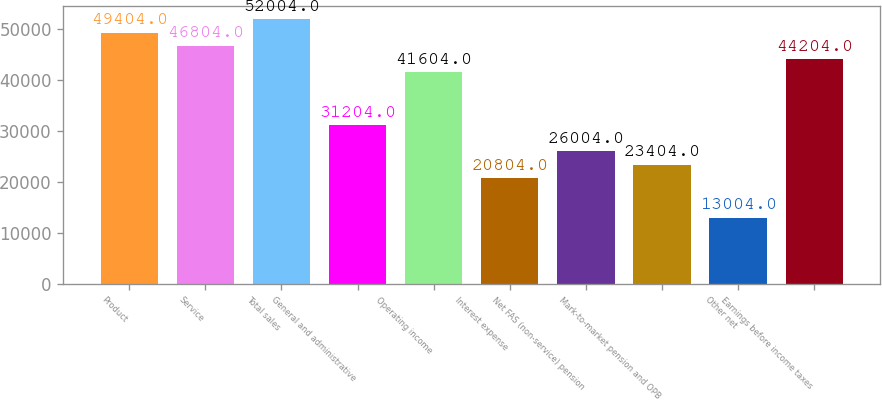Convert chart to OTSL. <chart><loc_0><loc_0><loc_500><loc_500><bar_chart><fcel>Product<fcel>Service<fcel>Total sales<fcel>General and administrative<fcel>Operating income<fcel>Interest expense<fcel>Net FAS (non-service) pension<fcel>Mark-to-market pension and OPB<fcel>Other net<fcel>Earnings before income taxes<nl><fcel>49404<fcel>46804<fcel>52004<fcel>31204<fcel>41604<fcel>20804<fcel>26004<fcel>23404<fcel>13004<fcel>44204<nl></chart> 